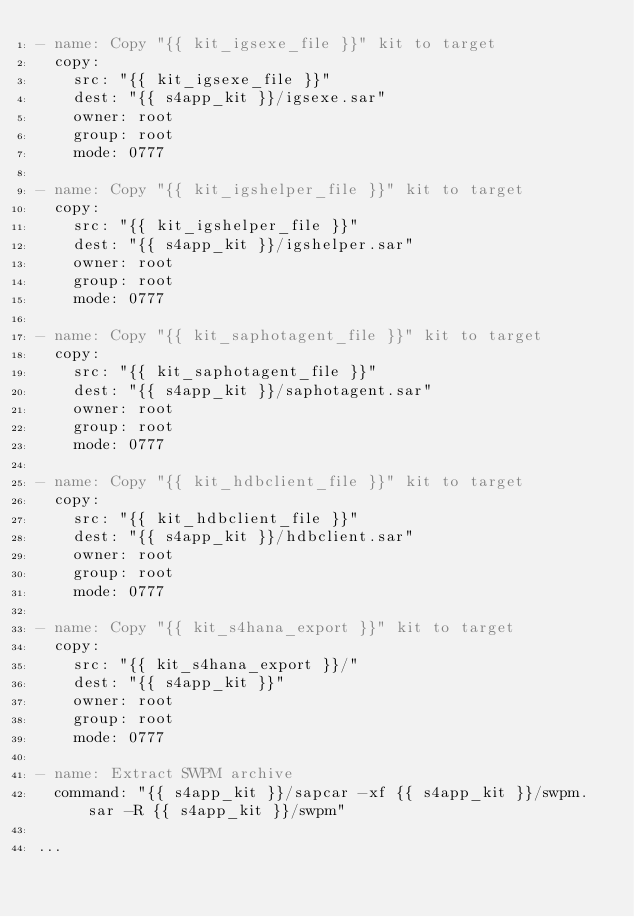Convert code to text. <code><loc_0><loc_0><loc_500><loc_500><_YAML_>- name: Copy "{{ kit_igsexe_file }}" kit to target
  copy:
    src: "{{ kit_igsexe_file }}"
    dest: "{{ s4app_kit }}/igsexe.sar"
    owner: root
    group: root
    mode: 0777

- name: Copy "{{ kit_igshelper_file }}" kit to target
  copy:
    src: "{{ kit_igshelper_file }}"
    dest: "{{ s4app_kit }}/igshelper.sar"
    owner: root
    group: root
    mode: 0777

- name: Copy "{{ kit_saphotagent_file }}" kit to target
  copy:
    src: "{{ kit_saphotagent_file }}"
    dest: "{{ s4app_kit }}/saphotagent.sar"
    owner: root
    group: root
    mode: 0777

- name: Copy "{{ kit_hdbclient_file }}" kit to target
  copy:
    src: "{{ kit_hdbclient_file }}"
    dest: "{{ s4app_kit }}/hdbclient.sar"
    owner: root
    group: root
    mode: 0777

- name: Copy "{{ kit_s4hana_export }}" kit to target
  copy:
    src: "{{ kit_s4hana_export }}/"
    dest: "{{ s4app_kit }}"
    owner: root
    group: root
    mode: 0777

- name: Extract SWPM archive
  command: "{{ s4app_kit }}/sapcar -xf {{ s4app_kit }}/swpm.sar -R {{ s4app_kit }}/swpm"

...
</code> 